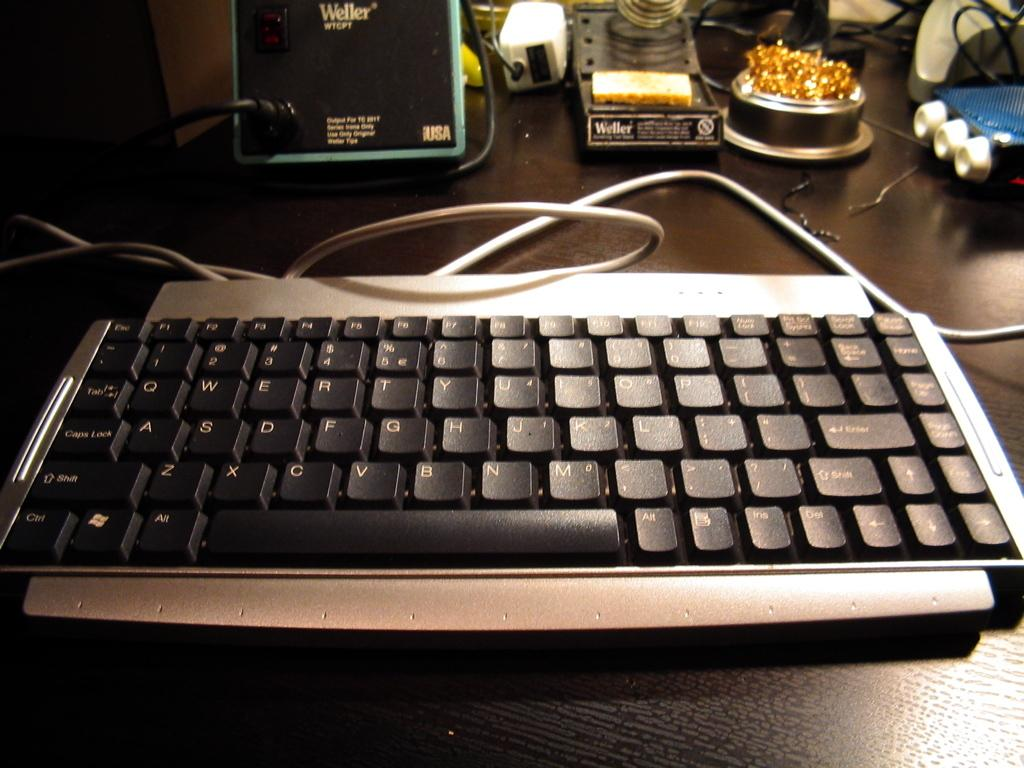<image>
Relay a brief, clear account of the picture shown. A keyboard place on a table in front of a Weller soldering iron. 